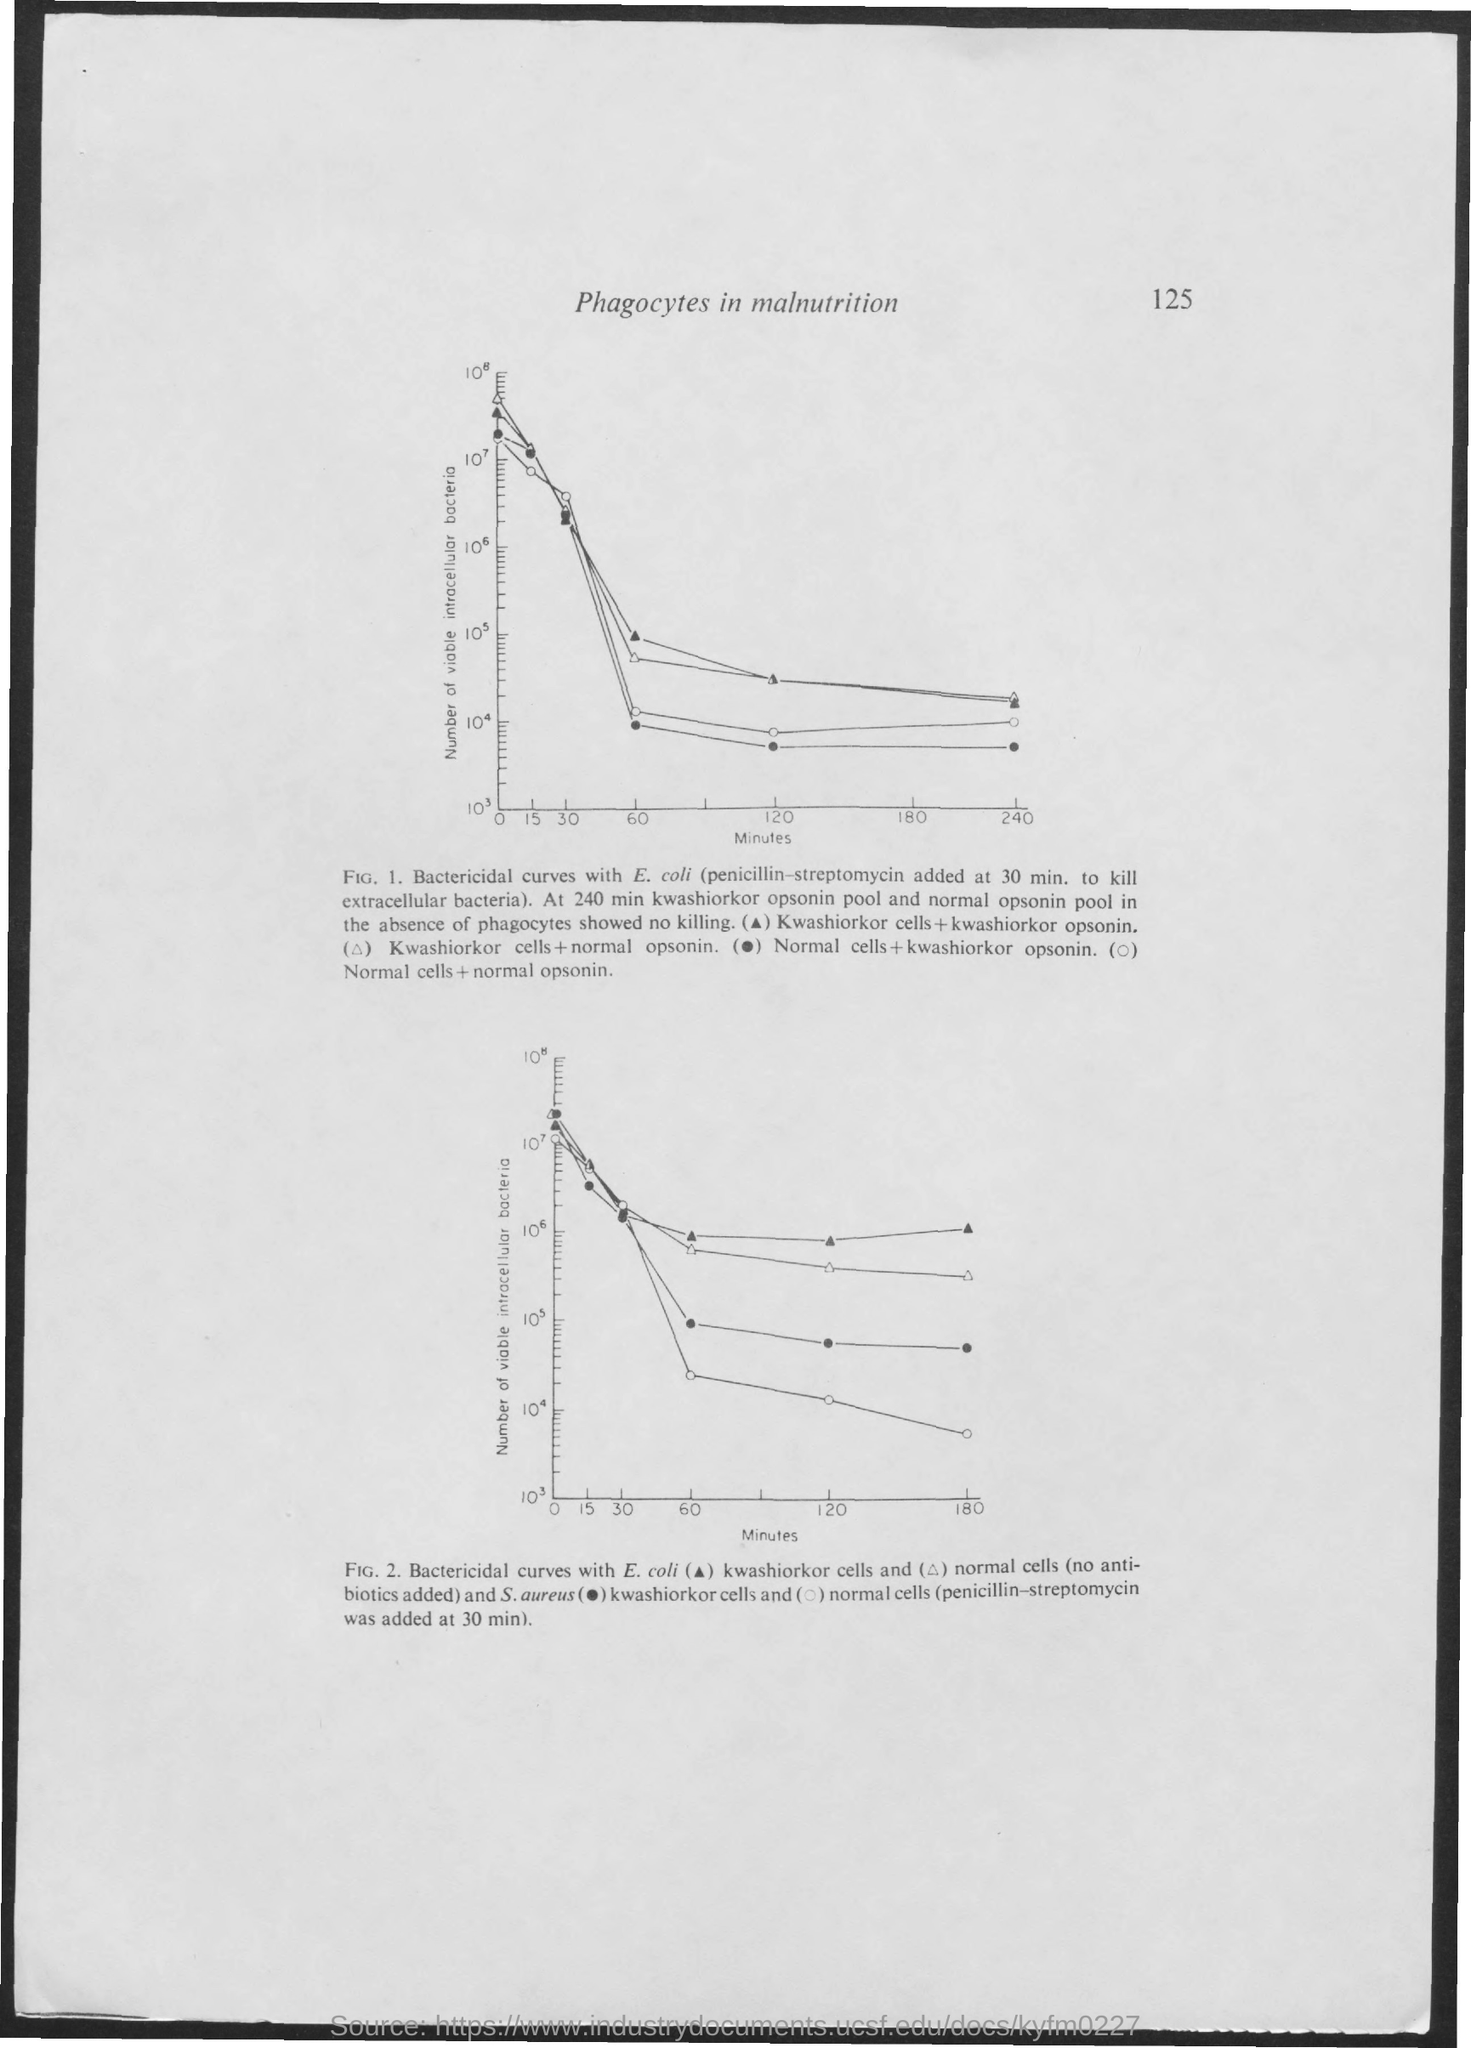Identify some key points in this picture. The page title is 'Phagocytes in Malnutrition'. The X-axis in Figure 1 represents minutes, which is one of the variables being plotted on the graph. The page number is 125. 